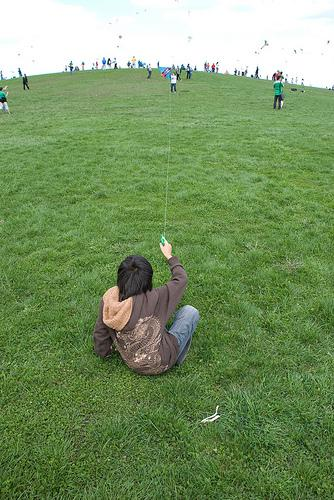Question: where was this photo taken?
Choices:
A. At the park.
B. The city.
C. The beach.
D. The mountains.
Answer with the letter. Answer: A Question: how many children are there?
Choices:
A. Fifty.
B. Ten.
C. Thirty.
D. Twenty.
Answer with the letter. Answer: C Question: what is the boy doing?
Choices:
A. Jumping.
B. Flying a kite.
C. Petting his dog.
D. Boating.
Answer with the letter. Answer: B 